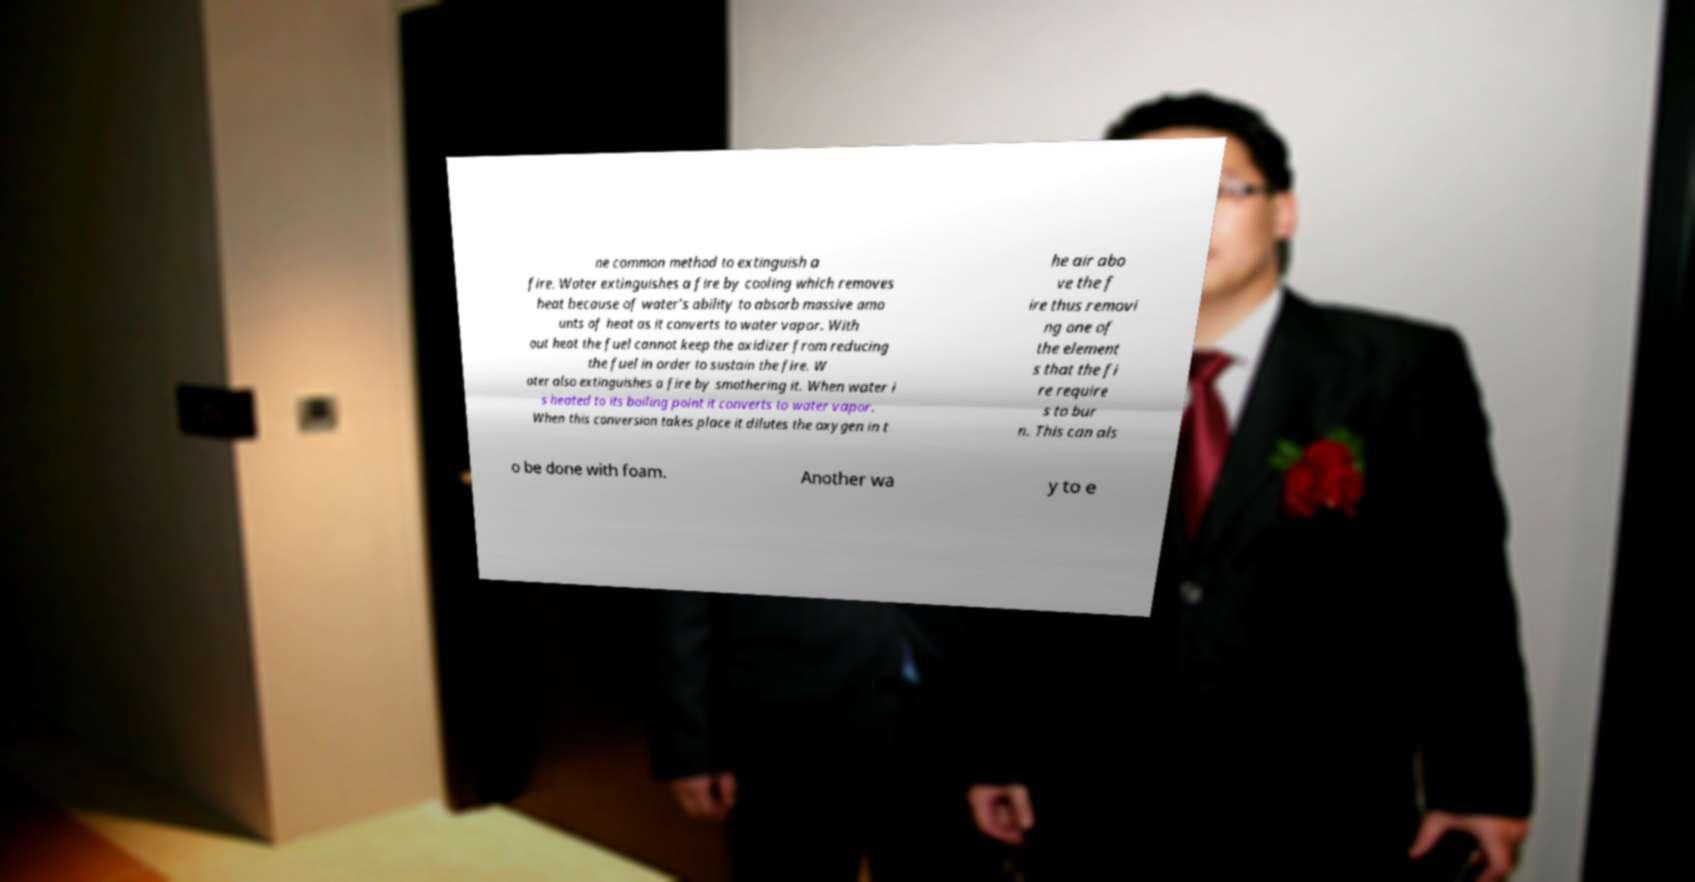For documentation purposes, I need the text within this image transcribed. Could you provide that? ne common method to extinguish a fire. Water extinguishes a fire by cooling which removes heat because of water’s ability to absorb massive amo unts of heat as it converts to water vapor. With out heat the fuel cannot keep the oxidizer from reducing the fuel in order to sustain the fire. W ater also extinguishes a fire by smothering it. When water i s heated to its boiling point it converts to water vapor. When this conversion takes place it dilutes the oxygen in t he air abo ve the f ire thus removi ng one of the element s that the fi re require s to bur n. This can als o be done with foam. Another wa y to e 